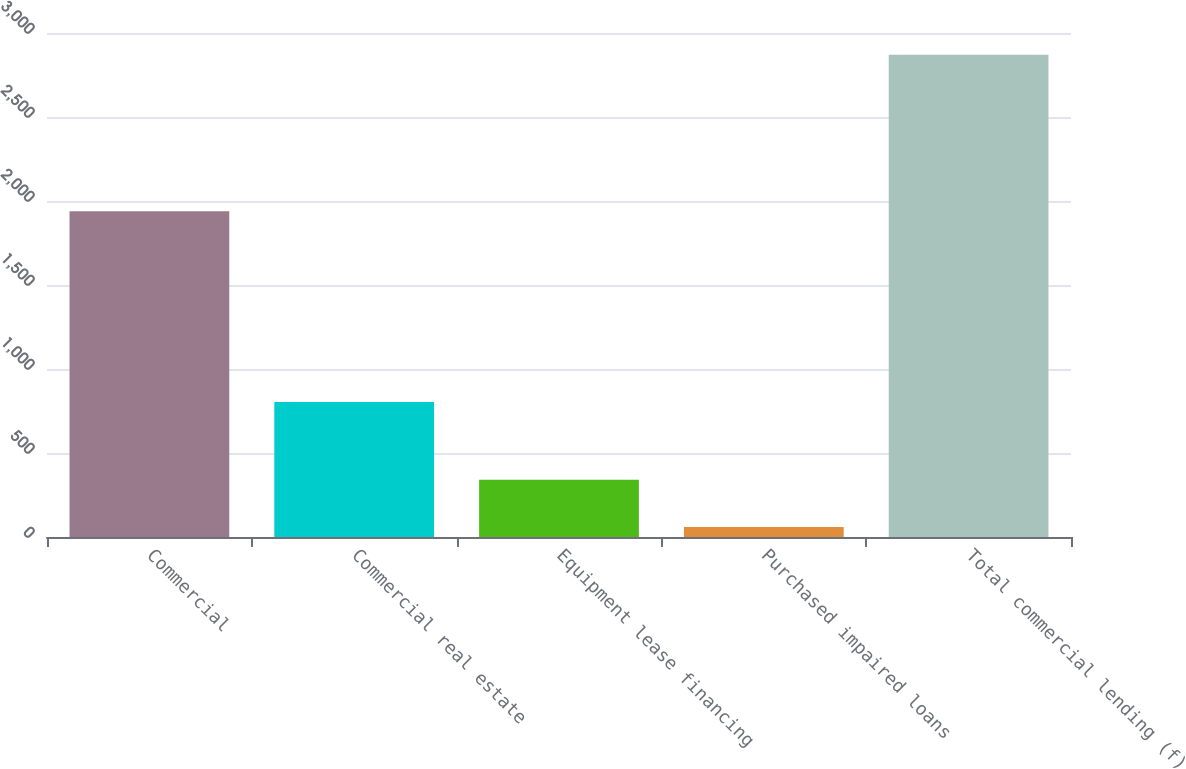Convert chart to OTSL. <chart><loc_0><loc_0><loc_500><loc_500><bar_chart><fcel>Commercial<fcel>Commercial real estate<fcel>Equipment lease financing<fcel>Purchased impaired loans<fcel>Total commercial lending (f)<nl><fcel>1939<fcel>804<fcel>341.1<fcel>60<fcel>2871<nl></chart> 